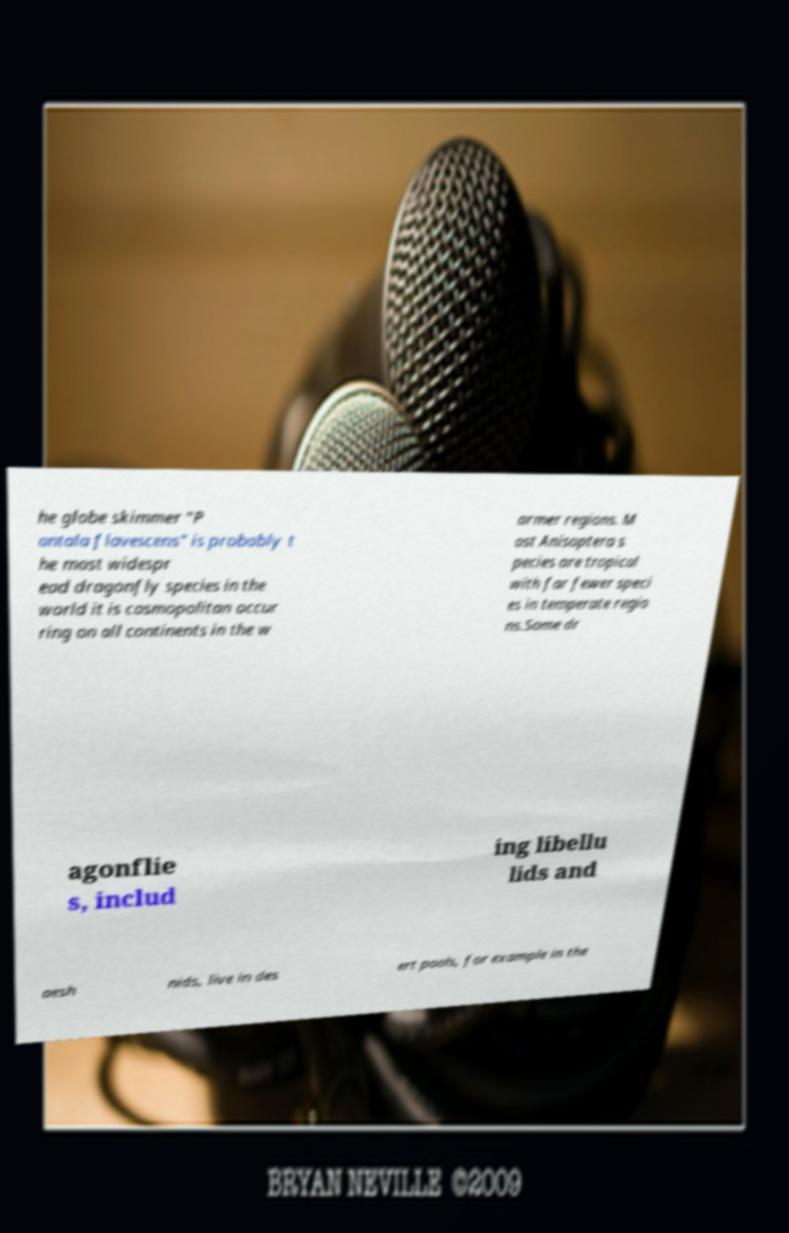Please read and relay the text visible in this image. What does it say? he globe skimmer "P antala flavescens" is probably t he most widespr ead dragonfly species in the world it is cosmopolitan occur ring on all continents in the w armer regions. M ost Anisoptera s pecies are tropical with far fewer speci es in temperate regio ns.Some dr agonflie s, includ ing libellu lids and aesh nids, live in des ert pools, for example in the 